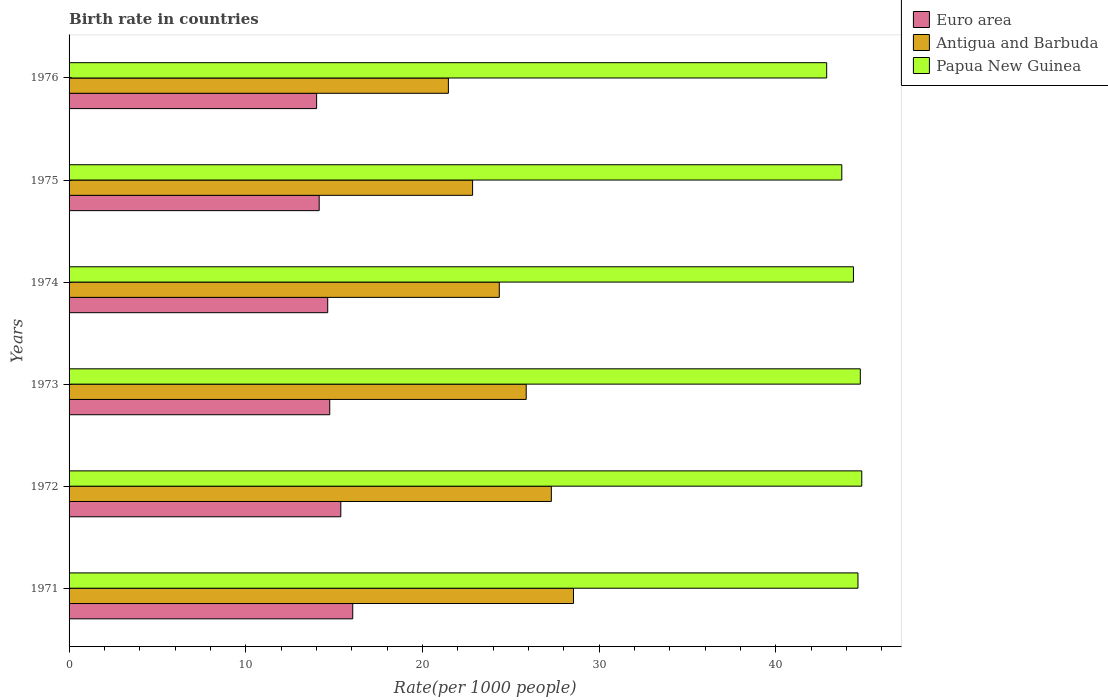How many different coloured bars are there?
Give a very brief answer. 3. Are the number of bars per tick equal to the number of legend labels?
Keep it short and to the point. Yes. What is the label of the 3rd group of bars from the top?
Provide a short and direct response. 1974. In how many cases, is the number of bars for a given year not equal to the number of legend labels?
Keep it short and to the point. 0. What is the birth rate in Papua New Guinea in 1972?
Make the answer very short. 44.86. Across all years, what is the maximum birth rate in Euro area?
Keep it short and to the point. 16.05. Across all years, what is the minimum birth rate in Papua New Guinea?
Offer a terse response. 42.88. In which year was the birth rate in Euro area maximum?
Keep it short and to the point. 1971. In which year was the birth rate in Antigua and Barbuda minimum?
Provide a short and direct response. 1976. What is the total birth rate in Euro area in the graph?
Your response must be concise. 88.99. What is the difference between the birth rate in Papua New Guinea in 1971 and that in 1976?
Keep it short and to the point. 1.77. What is the difference between the birth rate in Papua New Guinea in 1973 and the birth rate in Antigua and Barbuda in 1974?
Your response must be concise. 20.43. What is the average birth rate in Papua New Guinea per year?
Ensure brevity in your answer.  44.21. In the year 1975, what is the difference between the birth rate in Papua New Guinea and birth rate in Euro area?
Your response must be concise. 29.58. What is the ratio of the birth rate in Papua New Guinea in 1973 to that in 1975?
Offer a very short reply. 1.02. Is the birth rate in Papua New Guinea in 1974 less than that in 1975?
Give a very brief answer. No. Is the difference between the birth rate in Papua New Guinea in 1974 and 1976 greater than the difference between the birth rate in Euro area in 1974 and 1976?
Make the answer very short. Yes. What is the difference between the highest and the second highest birth rate in Papua New Guinea?
Keep it short and to the point. 0.08. What is the difference between the highest and the lowest birth rate in Antigua and Barbuda?
Make the answer very short. 7.08. In how many years, is the birth rate in Antigua and Barbuda greater than the average birth rate in Antigua and Barbuda taken over all years?
Make the answer very short. 3. Is the sum of the birth rate in Euro area in 1971 and 1974 greater than the maximum birth rate in Antigua and Barbuda across all years?
Offer a very short reply. Yes. What does the 3rd bar from the top in 1975 represents?
Offer a terse response. Euro area. What does the 2nd bar from the bottom in 1971 represents?
Keep it short and to the point. Antigua and Barbuda. Is it the case that in every year, the sum of the birth rate in Papua New Guinea and birth rate in Antigua and Barbuda is greater than the birth rate in Euro area?
Your answer should be compact. Yes. How many bars are there?
Your answer should be very brief. 18. Are all the bars in the graph horizontal?
Make the answer very short. Yes. Are the values on the major ticks of X-axis written in scientific E-notation?
Provide a short and direct response. No. Does the graph contain any zero values?
Your answer should be very brief. No. Does the graph contain grids?
Give a very brief answer. No. Where does the legend appear in the graph?
Provide a succinct answer. Top right. How many legend labels are there?
Ensure brevity in your answer.  3. What is the title of the graph?
Provide a succinct answer. Birth rate in countries. What is the label or title of the X-axis?
Offer a terse response. Rate(per 1000 people). What is the Rate(per 1000 people) of Euro area in 1971?
Offer a very short reply. 16.05. What is the Rate(per 1000 people) of Antigua and Barbuda in 1971?
Provide a succinct answer. 28.55. What is the Rate(per 1000 people) in Papua New Guinea in 1971?
Your response must be concise. 44.65. What is the Rate(per 1000 people) of Euro area in 1972?
Offer a very short reply. 15.38. What is the Rate(per 1000 people) in Antigua and Barbuda in 1972?
Your response must be concise. 27.29. What is the Rate(per 1000 people) of Papua New Guinea in 1972?
Give a very brief answer. 44.86. What is the Rate(per 1000 people) of Euro area in 1973?
Provide a short and direct response. 14.75. What is the Rate(per 1000 people) of Antigua and Barbuda in 1973?
Provide a short and direct response. 25.87. What is the Rate(per 1000 people) in Papua New Guinea in 1973?
Your answer should be compact. 44.78. What is the Rate(per 1000 people) in Euro area in 1974?
Keep it short and to the point. 14.64. What is the Rate(per 1000 people) of Antigua and Barbuda in 1974?
Your response must be concise. 24.35. What is the Rate(per 1000 people) of Papua New Guinea in 1974?
Provide a succinct answer. 44.39. What is the Rate(per 1000 people) of Euro area in 1975?
Provide a short and direct response. 14.15. What is the Rate(per 1000 people) in Antigua and Barbuda in 1975?
Offer a terse response. 22.84. What is the Rate(per 1000 people) of Papua New Guinea in 1975?
Give a very brief answer. 43.73. What is the Rate(per 1000 people) in Euro area in 1976?
Ensure brevity in your answer.  14.01. What is the Rate(per 1000 people) of Antigua and Barbuda in 1976?
Give a very brief answer. 21.47. What is the Rate(per 1000 people) of Papua New Guinea in 1976?
Provide a short and direct response. 42.88. Across all years, what is the maximum Rate(per 1000 people) in Euro area?
Your answer should be compact. 16.05. Across all years, what is the maximum Rate(per 1000 people) of Antigua and Barbuda?
Your answer should be compact. 28.55. Across all years, what is the maximum Rate(per 1000 people) in Papua New Guinea?
Give a very brief answer. 44.86. Across all years, what is the minimum Rate(per 1000 people) in Euro area?
Provide a succinct answer. 14.01. Across all years, what is the minimum Rate(per 1000 people) of Antigua and Barbuda?
Your answer should be compact. 21.47. Across all years, what is the minimum Rate(per 1000 people) in Papua New Guinea?
Your response must be concise. 42.88. What is the total Rate(per 1000 people) in Euro area in the graph?
Your response must be concise. 88.99. What is the total Rate(per 1000 people) of Antigua and Barbuda in the graph?
Your answer should be compact. 150.36. What is the total Rate(per 1000 people) in Papua New Guinea in the graph?
Ensure brevity in your answer.  265.28. What is the difference between the Rate(per 1000 people) in Euro area in 1971 and that in 1972?
Ensure brevity in your answer.  0.68. What is the difference between the Rate(per 1000 people) in Antigua and Barbuda in 1971 and that in 1972?
Offer a terse response. 1.25. What is the difference between the Rate(per 1000 people) in Papua New Guinea in 1971 and that in 1972?
Provide a succinct answer. -0.21. What is the difference between the Rate(per 1000 people) in Euro area in 1971 and that in 1973?
Keep it short and to the point. 1.3. What is the difference between the Rate(per 1000 people) in Antigua and Barbuda in 1971 and that in 1973?
Make the answer very short. 2.67. What is the difference between the Rate(per 1000 people) in Papua New Guinea in 1971 and that in 1973?
Your answer should be compact. -0.13. What is the difference between the Rate(per 1000 people) in Euro area in 1971 and that in 1974?
Ensure brevity in your answer.  1.42. What is the difference between the Rate(per 1000 people) of Antigua and Barbuda in 1971 and that in 1974?
Offer a terse response. 4.2. What is the difference between the Rate(per 1000 people) of Papua New Guinea in 1971 and that in 1974?
Provide a succinct answer. 0.26. What is the difference between the Rate(per 1000 people) in Euro area in 1971 and that in 1975?
Give a very brief answer. 1.9. What is the difference between the Rate(per 1000 people) in Antigua and Barbuda in 1971 and that in 1975?
Keep it short and to the point. 5.71. What is the difference between the Rate(per 1000 people) in Papua New Guinea in 1971 and that in 1975?
Your answer should be very brief. 0.92. What is the difference between the Rate(per 1000 people) in Euro area in 1971 and that in 1976?
Your answer should be very brief. 2.04. What is the difference between the Rate(per 1000 people) of Antigua and Barbuda in 1971 and that in 1976?
Provide a short and direct response. 7.08. What is the difference between the Rate(per 1000 people) of Papua New Guinea in 1971 and that in 1976?
Give a very brief answer. 1.77. What is the difference between the Rate(per 1000 people) in Euro area in 1972 and that in 1973?
Give a very brief answer. 0.63. What is the difference between the Rate(per 1000 people) of Antigua and Barbuda in 1972 and that in 1973?
Offer a terse response. 1.42. What is the difference between the Rate(per 1000 people) in Papua New Guinea in 1972 and that in 1973?
Provide a succinct answer. 0.08. What is the difference between the Rate(per 1000 people) in Euro area in 1972 and that in 1974?
Make the answer very short. 0.74. What is the difference between the Rate(per 1000 people) of Antigua and Barbuda in 1972 and that in 1974?
Provide a succinct answer. 2.94. What is the difference between the Rate(per 1000 people) of Papua New Guinea in 1972 and that in 1974?
Your answer should be compact. 0.47. What is the difference between the Rate(per 1000 people) in Euro area in 1972 and that in 1975?
Ensure brevity in your answer.  1.22. What is the difference between the Rate(per 1000 people) of Antigua and Barbuda in 1972 and that in 1975?
Your answer should be compact. 4.46. What is the difference between the Rate(per 1000 people) of Papua New Guinea in 1972 and that in 1975?
Your answer should be very brief. 1.13. What is the difference between the Rate(per 1000 people) of Euro area in 1972 and that in 1976?
Your answer should be very brief. 1.37. What is the difference between the Rate(per 1000 people) in Antigua and Barbuda in 1972 and that in 1976?
Provide a succinct answer. 5.83. What is the difference between the Rate(per 1000 people) in Papua New Guinea in 1972 and that in 1976?
Your response must be concise. 1.99. What is the difference between the Rate(per 1000 people) in Euro area in 1973 and that in 1974?
Make the answer very short. 0.11. What is the difference between the Rate(per 1000 people) in Antigua and Barbuda in 1973 and that in 1974?
Your answer should be compact. 1.52. What is the difference between the Rate(per 1000 people) in Papua New Guinea in 1973 and that in 1974?
Offer a very short reply. 0.39. What is the difference between the Rate(per 1000 people) in Euro area in 1973 and that in 1975?
Give a very brief answer. 0.6. What is the difference between the Rate(per 1000 people) in Antigua and Barbuda in 1973 and that in 1975?
Make the answer very short. 3.03. What is the difference between the Rate(per 1000 people) of Papua New Guinea in 1973 and that in 1975?
Give a very brief answer. 1.05. What is the difference between the Rate(per 1000 people) of Euro area in 1973 and that in 1976?
Keep it short and to the point. 0.74. What is the difference between the Rate(per 1000 people) of Antigua and Barbuda in 1973 and that in 1976?
Offer a terse response. 4.4. What is the difference between the Rate(per 1000 people) in Papua New Guinea in 1973 and that in 1976?
Make the answer very short. 1.9. What is the difference between the Rate(per 1000 people) in Euro area in 1974 and that in 1975?
Offer a terse response. 0.48. What is the difference between the Rate(per 1000 people) of Antigua and Barbuda in 1974 and that in 1975?
Your answer should be very brief. 1.51. What is the difference between the Rate(per 1000 people) of Papua New Guinea in 1974 and that in 1975?
Provide a short and direct response. 0.66. What is the difference between the Rate(per 1000 people) of Euro area in 1974 and that in 1976?
Keep it short and to the point. 0.63. What is the difference between the Rate(per 1000 people) in Antigua and Barbuda in 1974 and that in 1976?
Give a very brief answer. 2.88. What is the difference between the Rate(per 1000 people) of Papua New Guinea in 1974 and that in 1976?
Provide a succinct answer. 1.51. What is the difference between the Rate(per 1000 people) in Euro area in 1975 and that in 1976?
Provide a short and direct response. 0.14. What is the difference between the Rate(per 1000 people) of Antigua and Barbuda in 1975 and that in 1976?
Make the answer very short. 1.37. What is the difference between the Rate(per 1000 people) of Papua New Guinea in 1975 and that in 1976?
Provide a succinct answer. 0.85. What is the difference between the Rate(per 1000 people) in Euro area in 1971 and the Rate(per 1000 people) in Antigua and Barbuda in 1972?
Your response must be concise. -11.24. What is the difference between the Rate(per 1000 people) of Euro area in 1971 and the Rate(per 1000 people) of Papua New Guinea in 1972?
Give a very brief answer. -28.81. What is the difference between the Rate(per 1000 people) in Antigua and Barbuda in 1971 and the Rate(per 1000 people) in Papua New Guinea in 1972?
Your answer should be very brief. -16.32. What is the difference between the Rate(per 1000 people) in Euro area in 1971 and the Rate(per 1000 people) in Antigua and Barbuda in 1973?
Make the answer very short. -9.82. What is the difference between the Rate(per 1000 people) in Euro area in 1971 and the Rate(per 1000 people) in Papua New Guinea in 1973?
Your answer should be very brief. -28.72. What is the difference between the Rate(per 1000 people) of Antigua and Barbuda in 1971 and the Rate(per 1000 people) of Papua New Guinea in 1973?
Provide a succinct answer. -16.23. What is the difference between the Rate(per 1000 people) of Euro area in 1971 and the Rate(per 1000 people) of Antigua and Barbuda in 1974?
Provide a short and direct response. -8.29. What is the difference between the Rate(per 1000 people) of Euro area in 1971 and the Rate(per 1000 people) of Papua New Guinea in 1974?
Offer a terse response. -28.34. What is the difference between the Rate(per 1000 people) in Antigua and Barbuda in 1971 and the Rate(per 1000 people) in Papua New Guinea in 1974?
Your answer should be very brief. -15.85. What is the difference between the Rate(per 1000 people) in Euro area in 1971 and the Rate(per 1000 people) in Antigua and Barbuda in 1975?
Keep it short and to the point. -6.78. What is the difference between the Rate(per 1000 people) in Euro area in 1971 and the Rate(per 1000 people) in Papua New Guinea in 1975?
Your response must be concise. -27.68. What is the difference between the Rate(per 1000 people) of Antigua and Barbuda in 1971 and the Rate(per 1000 people) of Papua New Guinea in 1975?
Your response must be concise. -15.19. What is the difference between the Rate(per 1000 people) in Euro area in 1971 and the Rate(per 1000 people) in Antigua and Barbuda in 1976?
Ensure brevity in your answer.  -5.41. What is the difference between the Rate(per 1000 people) of Euro area in 1971 and the Rate(per 1000 people) of Papua New Guinea in 1976?
Offer a very short reply. -26.82. What is the difference between the Rate(per 1000 people) in Antigua and Barbuda in 1971 and the Rate(per 1000 people) in Papua New Guinea in 1976?
Provide a short and direct response. -14.33. What is the difference between the Rate(per 1000 people) of Euro area in 1972 and the Rate(per 1000 people) of Antigua and Barbuda in 1973?
Your response must be concise. -10.49. What is the difference between the Rate(per 1000 people) of Euro area in 1972 and the Rate(per 1000 people) of Papua New Guinea in 1973?
Make the answer very short. -29.4. What is the difference between the Rate(per 1000 people) of Antigua and Barbuda in 1972 and the Rate(per 1000 people) of Papua New Guinea in 1973?
Your answer should be compact. -17.49. What is the difference between the Rate(per 1000 people) of Euro area in 1972 and the Rate(per 1000 people) of Antigua and Barbuda in 1974?
Your response must be concise. -8.97. What is the difference between the Rate(per 1000 people) in Euro area in 1972 and the Rate(per 1000 people) in Papua New Guinea in 1974?
Provide a short and direct response. -29.01. What is the difference between the Rate(per 1000 people) in Antigua and Barbuda in 1972 and the Rate(per 1000 people) in Papua New Guinea in 1974?
Give a very brief answer. -17.1. What is the difference between the Rate(per 1000 people) in Euro area in 1972 and the Rate(per 1000 people) in Antigua and Barbuda in 1975?
Make the answer very short. -7.46. What is the difference between the Rate(per 1000 people) of Euro area in 1972 and the Rate(per 1000 people) of Papua New Guinea in 1975?
Provide a succinct answer. -28.35. What is the difference between the Rate(per 1000 people) of Antigua and Barbuda in 1972 and the Rate(per 1000 people) of Papua New Guinea in 1975?
Your answer should be very brief. -16.44. What is the difference between the Rate(per 1000 people) of Euro area in 1972 and the Rate(per 1000 people) of Antigua and Barbuda in 1976?
Your answer should be compact. -6.09. What is the difference between the Rate(per 1000 people) in Euro area in 1972 and the Rate(per 1000 people) in Papua New Guinea in 1976?
Offer a terse response. -27.5. What is the difference between the Rate(per 1000 people) of Antigua and Barbuda in 1972 and the Rate(per 1000 people) of Papua New Guinea in 1976?
Your answer should be very brief. -15.58. What is the difference between the Rate(per 1000 people) of Euro area in 1973 and the Rate(per 1000 people) of Antigua and Barbuda in 1974?
Provide a short and direct response. -9.6. What is the difference between the Rate(per 1000 people) of Euro area in 1973 and the Rate(per 1000 people) of Papua New Guinea in 1974?
Offer a very short reply. -29.64. What is the difference between the Rate(per 1000 people) of Antigua and Barbuda in 1973 and the Rate(per 1000 people) of Papua New Guinea in 1974?
Provide a short and direct response. -18.52. What is the difference between the Rate(per 1000 people) in Euro area in 1973 and the Rate(per 1000 people) in Antigua and Barbuda in 1975?
Keep it short and to the point. -8.08. What is the difference between the Rate(per 1000 people) of Euro area in 1973 and the Rate(per 1000 people) of Papua New Guinea in 1975?
Offer a very short reply. -28.98. What is the difference between the Rate(per 1000 people) in Antigua and Barbuda in 1973 and the Rate(per 1000 people) in Papua New Guinea in 1975?
Provide a succinct answer. -17.86. What is the difference between the Rate(per 1000 people) in Euro area in 1973 and the Rate(per 1000 people) in Antigua and Barbuda in 1976?
Your answer should be very brief. -6.71. What is the difference between the Rate(per 1000 people) of Euro area in 1973 and the Rate(per 1000 people) of Papua New Guinea in 1976?
Provide a succinct answer. -28.12. What is the difference between the Rate(per 1000 people) of Antigua and Barbuda in 1973 and the Rate(per 1000 people) of Papua New Guinea in 1976?
Offer a terse response. -17. What is the difference between the Rate(per 1000 people) of Euro area in 1974 and the Rate(per 1000 people) of Antigua and Barbuda in 1975?
Keep it short and to the point. -8.2. What is the difference between the Rate(per 1000 people) of Euro area in 1974 and the Rate(per 1000 people) of Papua New Guinea in 1975?
Your answer should be compact. -29.09. What is the difference between the Rate(per 1000 people) in Antigua and Barbuda in 1974 and the Rate(per 1000 people) in Papua New Guinea in 1975?
Provide a succinct answer. -19.38. What is the difference between the Rate(per 1000 people) of Euro area in 1974 and the Rate(per 1000 people) of Antigua and Barbuda in 1976?
Keep it short and to the point. -6.83. What is the difference between the Rate(per 1000 people) in Euro area in 1974 and the Rate(per 1000 people) in Papua New Guinea in 1976?
Your answer should be compact. -28.24. What is the difference between the Rate(per 1000 people) in Antigua and Barbuda in 1974 and the Rate(per 1000 people) in Papua New Guinea in 1976?
Ensure brevity in your answer.  -18.53. What is the difference between the Rate(per 1000 people) of Euro area in 1975 and the Rate(per 1000 people) of Antigua and Barbuda in 1976?
Offer a very short reply. -7.31. What is the difference between the Rate(per 1000 people) of Euro area in 1975 and the Rate(per 1000 people) of Papua New Guinea in 1976?
Offer a very short reply. -28.72. What is the difference between the Rate(per 1000 people) of Antigua and Barbuda in 1975 and the Rate(per 1000 people) of Papua New Guinea in 1976?
Provide a short and direct response. -20.04. What is the average Rate(per 1000 people) in Euro area per year?
Your response must be concise. 14.83. What is the average Rate(per 1000 people) in Antigua and Barbuda per year?
Offer a very short reply. 25.06. What is the average Rate(per 1000 people) of Papua New Guinea per year?
Offer a very short reply. 44.21. In the year 1971, what is the difference between the Rate(per 1000 people) of Euro area and Rate(per 1000 people) of Antigua and Barbuda?
Your response must be concise. -12.49. In the year 1971, what is the difference between the Rate(per 1000 people) of Euro area and Rate(per 1000 people) of Papua New Guinea?
Offer a very short reply. -28.59. In the year 1971, what is the difference between the Rate(per 1000 people) of Antigua and Barbuda and Rate(per 1000 people) of Papua New Guinea?
Your answer should be very brief. -16.1. In the year 1972, what is the difference between the Rate(per 1000 people) of Euro area and Rate(per 1000 people) of Antigua and Barbuda?
Offer a terse response. -11.91. In the year 1972, what is the difference between the Rate(per 1000 people) in Euro area and Rate(per 1000 people) in Papua New Guinea?
Offer a very short reply. -29.48. In the year 1972, what is the difference between the Rate(per 1000 people) in Antigua and Barbuda and Rate(per 1000 people) in Papua New Guinea?
Provide a succinct answer. -17.57. In the year 1973, what is the difference between the Rate(per 1000 people) of Euro area and Rate(per 1000 people) of Antigua and Barbuda?
Your response must be concise. -11.12. In the year 1973, what is the difference between the Rate(per 1000 people) in Euro area and Rate(per 1000 people) in Papua New Guinea?
Offer a terse response. -30.03. In the year 1973, what is the difference between the Rate(per 1000 people) of Antigua and Barbuda and Rate(per 1000 people) of Papua New Guinea?
Ensure brevity in your answer.  -18.91. In the year 1974, what is the difference between the Rate(per 1000 people) of Euro area and Rate(per 1000 people) of Antigua and Barbuda?
Give a very brief answer. -9.71. In the year 1974, what is the difference between the Rate(per 1000 people) in Euro area and Rate(per 1000 people) in Papua New Guinea?
Your answer should be compact. -29.75. In the year 1974, what is the difference between the Rate(per 1000 people) in Antigua and Barbuda and Rate(per 1000 people) in Papua New Guinea?
Offer a terse response. -20.04. In the year 1975, what is the difference between the Rate(per 1000 people) in Euro area and Rate(per 1000 people) in Antigua and Barbuda?
Keep it short and to the point. -8.68. In the year 1975, what is the difference between the Rate(per 1000 people) of Euro area and Rate(per 1000 people) of Papua New Guinea?
Keep it short and to the point. -29.58. In the year 1975, what is the difference between the Rate(per 1000 people) of Antigua and Barbuda and Rate(per 1000 people) of Papua New Guinea?
Provide a succinct answer. -20.89. In the year 1976, what is the difference between the Rate(per 1000 people) in Euro area and Rate(per 1000 people) in Antigua and Barbuda?
Ensure brevity in your answer.  -7.46. In the year 1976, what is the difference between the Rate(per 1000 people) of Euro area and Rate(per 1000 people) of Papua New Guinea?
Provide a short and direct response. -28.87. In the year 1976, what is the difference between the Rate(per 1000 people) of Antigua and Barbuda and Rate(per 1000 people) of Papua New Guinea?
Make the answer very short. -21.41. What is the ratio of the Rate(per 1000 people) in Euro area in 1971 to that in 1972?
Give a very brief answer. 1.04. What is the ratio of the Rate(per 1000 people) of Antigua and Barbuda in 1971 to that in 1972?
Ensure brevity in your answer.  1.05. What is the ratio of the Rate(per 1000 people) in Papua New Guinea in 1971 to that in 1972?
Give a very brief answer. 1. What is the ratio of the Rate(per 1000 people) of Euro area in 1971 to that in 1973?
Your answer should be very brief. 1.09. What is the ratio of the Rate(per 1000 people) of Antigua and Barbuda in 1971 to that in 1973?
Make the answer very short. 1.1. What is the ratio of the Rate(per 1000 people) of Euro area in 1971 to that in 1974?
Your answer should be very brief. 1.1. What is the ratio of the Rate(per 1000 people) of Antigua and Barbuda in 1971 to that in 1974?
Your response must be concise. 1.17. What is the ratio of the Rate(per 1000 people) in Papua New Guinea in 1971 to that in 1974?
Ensure brevity in your answer.  1.01. What is the ratio of the Rate(per 1000 people) of Euro area in 1971 to that in 1975?
Keep it short and to the point. 1.13. What is the ratio of the Rate(per 1000 people) in Antigua and Barbuda in 1971 to that in 1975?
Your response must be concise. 1.25. What is the ratio of the Rate(per 1000 people) in Papua New Guinea in 1971 to that in 1975?
Offer a very short reply. 1.02. What is the ratio of the Rate(per 1000 people) of Euro area in 1971 to that in 1976?
Your answer should be compact. 1.15. What is the ratio of the Rate(per 1000 people) in Antigua and Barbuda in 1971 to that in 1976?
Provide a succinct answer. 1.33. What is the ratio of the Rate(per 1000 people) of Papua New Guinea in 1971 to that in 1976?
Your response must be concise. 1.04. What is the ratio of the Rate(per 1000 people) of Euro area in 1972 to that in 1973?
Your answer should be very brief. 1.04. What is the ratio of the Rate(per 1000 people) in Antigua and Barbuda in 1972 to that in 1973?
Make the answer very short. 1.05. What is the ratio of the Rate(per 1000 people) in Papua New Guinea in 1972 to that in 1973?
Ensure brevity in your answer.  1. What is the ratio of the Rate(per 1000 people) in Euro area in 1972 to that in 1974?
Provide a short and direct response. 1.05. What is the ratio of the Rate(per 1000 people) in Antigua and Barbuda in 1972 to that in 1974?
Provide a short and direct response. 1.12. What is the ratio of the Rate(per 1000 people) of Papua New Guinea in 1972 to that in 1974?
Provide a succinct answer. 1.01. What is the ratio of the Rate(per 1000 people) of Euro area in 1972 to that in 1975?
Your answer should be very brief. 1.09. What is the ratio of the Rate(per 1000 people) of Antigua and Barbuda in 1972 to that in 1975?
Provide a short and direct response. 1.2. What is the ratio of the Rate(per 1000 people) of Papua New Guinea in 1972 to that in 1975?
Provide a short and direct response. 1.03. What is the ratio of the Rate(per 1000 people) of Euro area in 1972 to that in 1976?
Ensure brevity in your answer.  1.1. What is the ratio of the Rate(per 1000 people) of Antigua and Barbuda in 1972 to that in 1976?
Make the answer very short. 1.27. What is the ratio of the Rate(per 1000 people) of Papua New Guinea in 1972 to that in 1976?
Provide a short and direct response. 1.05. What is the ratio of the Rate(per 1000 people) of Antigua and Barbuda in 1973 to that in 1974?
Ensure brevity in your answer.  1.06. What is the ratio of the Rate(per 1000 people) in Papua New Guinea in 1973 to that in 1974?
Give a very brief answer. 1.01. What is the ratio of the Rate(per 1000 people) of Euro area in 1973 to that in 1975?
Your answer should be very brief. 1.04. What is the ratio of the Rate(per 1000 people) of Antigua and Barbuda in 1973 to that in 1975?
Make the answer very short. 1.13. What is the ratio of the Rate(per 1000 people) of Euro area in 1973 to that in 1976?
Offer a terse response. 1.05. What is the ratio of the Rate(per 1000 people) in Antigua and Barbuda in 1973 to that in 1976?
Make the answer very short. 1.21. What is the ratio of the Rate(per 1000 people) of Papua New Guinea in 1973 to that in 1976?
Provide a short and direct response. 1.04. What is the ratio of the Rate(per 1000 people) in Euro area in 1974 to that in 1975?
Ensure brevity in your answer.  1.03. What is the ratio of the Rate(per 1000 people) in Antigua and Barbuda in 1974 to that in 1975?
Offer a terse response. 1.07. What is the ratio of the Rate(per 1000 people) of Papua New Guinea in 1974 to that in 1975?
Offer a terse response. 1.02. What is the ratio of the Rate(per 1000 people) of Euro area in 1974 to that in 1976?
Your answer should be compact. 1.04. What is the ratio of the Rate(per 1000 people) in Antigua and Barbuda in 1974 to that in 1976?
Your answer should be very brief. 1.13. What is the ratio of the Rate(per 1000 people) of Papua New Guinea in 1974 to that in 1976?
Your answer should be compact. 1.04. What is the ratio of the Rate(per 1000 people) of Euro area in 1975 to that in 1976?
Provide a succinct answer. 1.01. What is the ratio of the Rate(per 1000 people) in Antigua and Barbuda in 1975 to that in 1976?
Your response must be concise. 1.06. What is the ratio of the Rate(per 1000 people) of Papua New Guinea in 1975 to that in 1976?
Offer a very short reply. 1.02. What is the difference between the highest and the second highest Rate(per 1000 people) in Euro area?
Offer a terse response. 0.68. What is the difference between the highest and the second highest Rate(per 1000 people) of Antigua and Barbuda?
Your answer should be compact. 1.25. What is the difference between the highest and the second highest Rate(per 1000 people) of Papua New Guinea?
Ensure brevity in your answer.  0.08. What is the difference between the highest and the lowest Rate(per 1000 people) of Euro area?
Offer a very short reply. 2.04. What is the difference between the highest and the lowest Rate(per 1000 people) of Antigua and Barbuda?
Make the answer very short. 7.08. What is the difference between the highest and the lowest Rate(per 1000 people) in Papua New Guinea?
Make the answer very short. 1.99. 